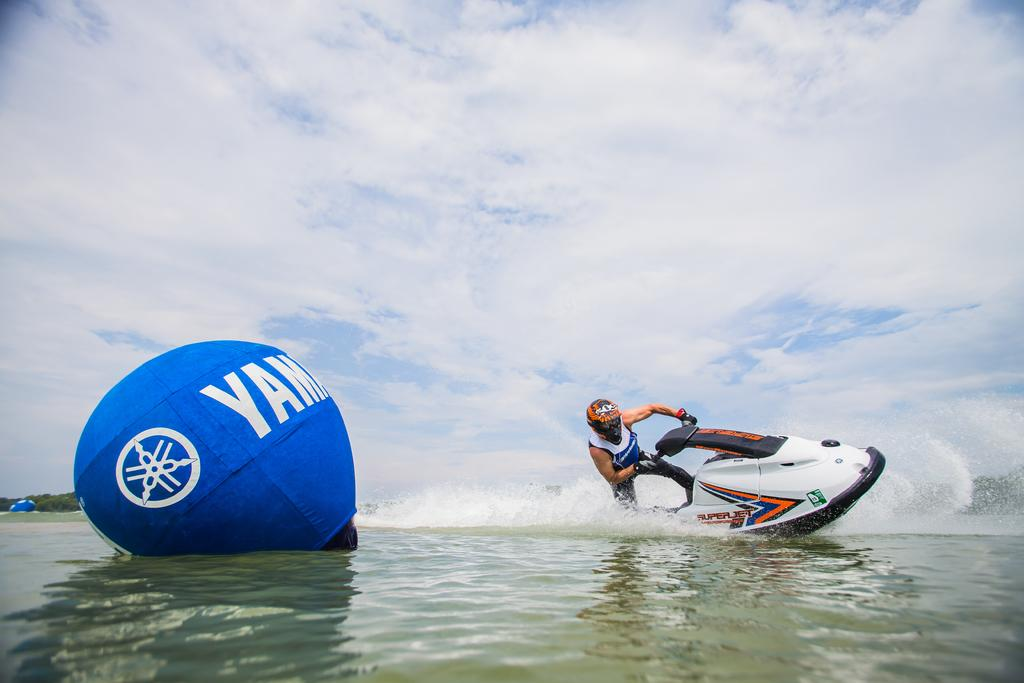What is the man in the image doing? The man is riding a jet ski on the water. What is the man wearing while riding the jet ski? The man is wearing a helmet. What can be seen beside the man while he is riding the jet ski? There is a balloon beside the man. What is visible in the background of the image? Trees and clouds are visible in the background of the image. What year is the man's account number for the jet ski rental? There is no information about the man's account number or the year in the image. 